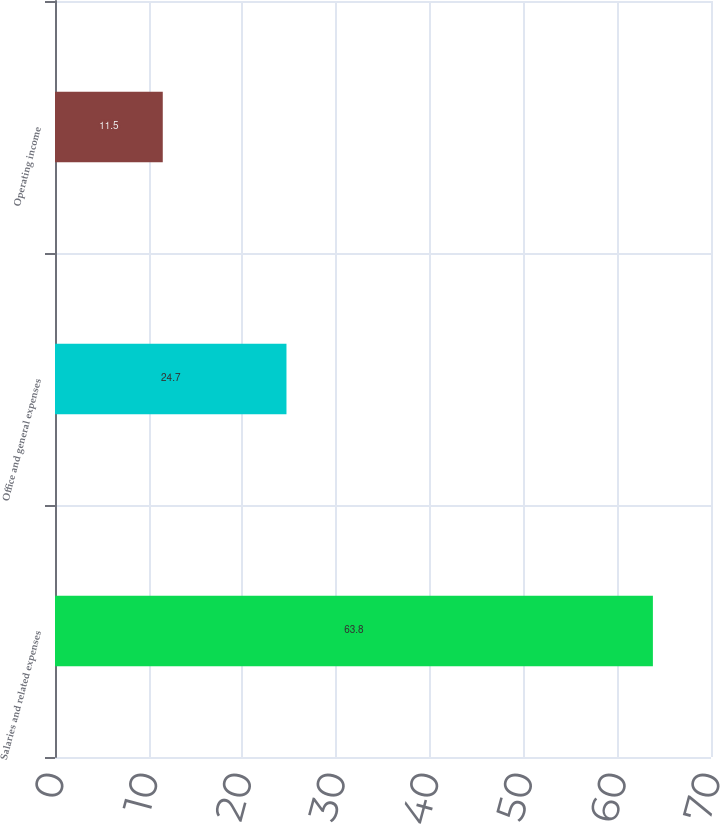Convert chart. <chart><loc_0><loc_0><loc_500><loc_500><bar_chart><fcel>Salaries and related expenses<fcel>Office and general expenses<fcel>Operating income<nl><fcel>63.8<fcel>24.7<fcel>11.5<nl></chart> 